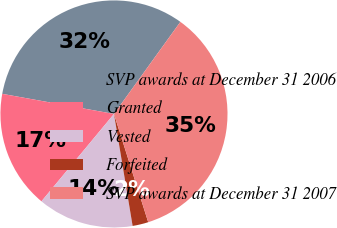Convert chart to OTSL. <chart><loc_0><loc_0><loc_500><loc_500><pie_chart><fcel>SVP awards at December 31 2006<fcel>Granted<fcel>Vested<fcel>Forfeited<fcel>SVP awards at December 31 2007<nl><fcel>32.11%<fcel>16.81%<fcel>13.65%<fcel>2.25%<fcel>35.18%<nl></chart> 